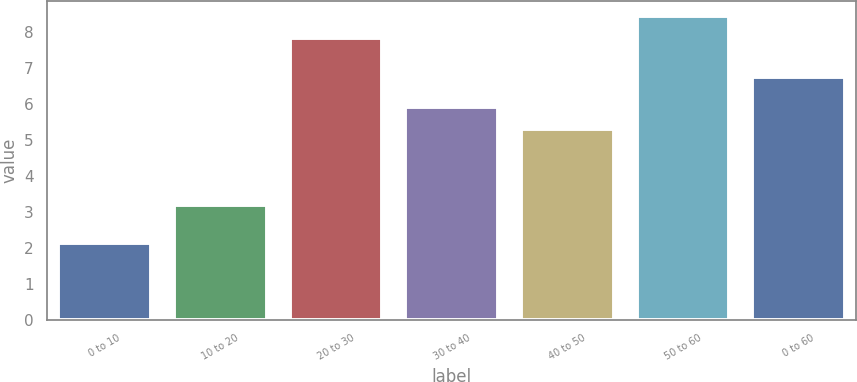Convert chart to OTSL. <chart><loc_0><loc_0><loc_500><loc_500><bar_chart><fcel>0 to 10<fcel>10 to 20<fcel>20 to 30<fcel>30 to 40<fcel>40 to 50<fcel>50 to 60<fcel>0 to 60<nl><fcel>2.15<fcel>3.19<fcel>7.84<fcel>5.93<fcel>5.32<fcel>8.45<fcel>6.75<nl></chart> 